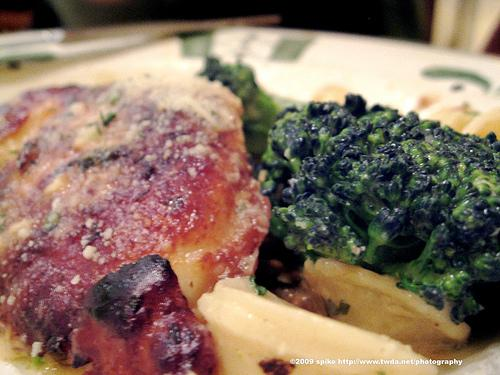How would you describe the state of the broccoli and its accompaniments? The broccoli is green and looks cooked, covered in a dark sauce, and possibly paired with white food items underneath it, which together create a visually appealing dish. In a few words, describe the overall presentation of the food on the plate. The food on the plate is artfully presented, with a mix of cooked meat, green vegetables, white food items, and sauce, all showcased on a plate with a green design. What types of vegetables are in the image and how are they prepared?  The image includes green broccoli that is possibly covered in sauce, other green vegetables such as kale, and a white food item under the broccoli, all cooked and served on the plate together. What is the main focus of the image and its features? The main focus of the image is a plate of cooked food with meat, vegetables, and a sauce, featuring items such as green broccoli and golden brown meat. Write a brief description of the image, focusing on the colors and textures of the objects. The image displays a plate of food with a green design, containing green broccoli covered in dark sauce, golden brown cooked meat, and white food items with a soft texture. Explain what type of meat is present and how it has been prepared. The image features cooked meat that appears to be golden brown, with seasoning, cheese, and herbs on top, suggesting it might be grilled or roasted. Identify the objects on the plate and their appearance. The plate contains cooked meat with seasoning, green broccoli with a sauce, a white food item under the broccoli, and a banana at the bottom, all on a plate with a green design. Describe the seasoning and toppings on the meat. The seasoning on the meat includes cheese, herbs, and other spices, giving it added flavor and an appealing appearance. Write a concise description of the image, aimed at an audience interested in the presentation of the food. The image showcases a beautifully arranged plate of cooked food, featuring golden brown meat with seasonings, vibrant green broccoli with a sauce, a white food item, and a banana, all on a plate with a green design. Tell me about the plate's design and how it complements the food. The plate has a green design, which complements the green broccoli and kale, providing a visually appealing contrast to the golden brown meat and white food items. 